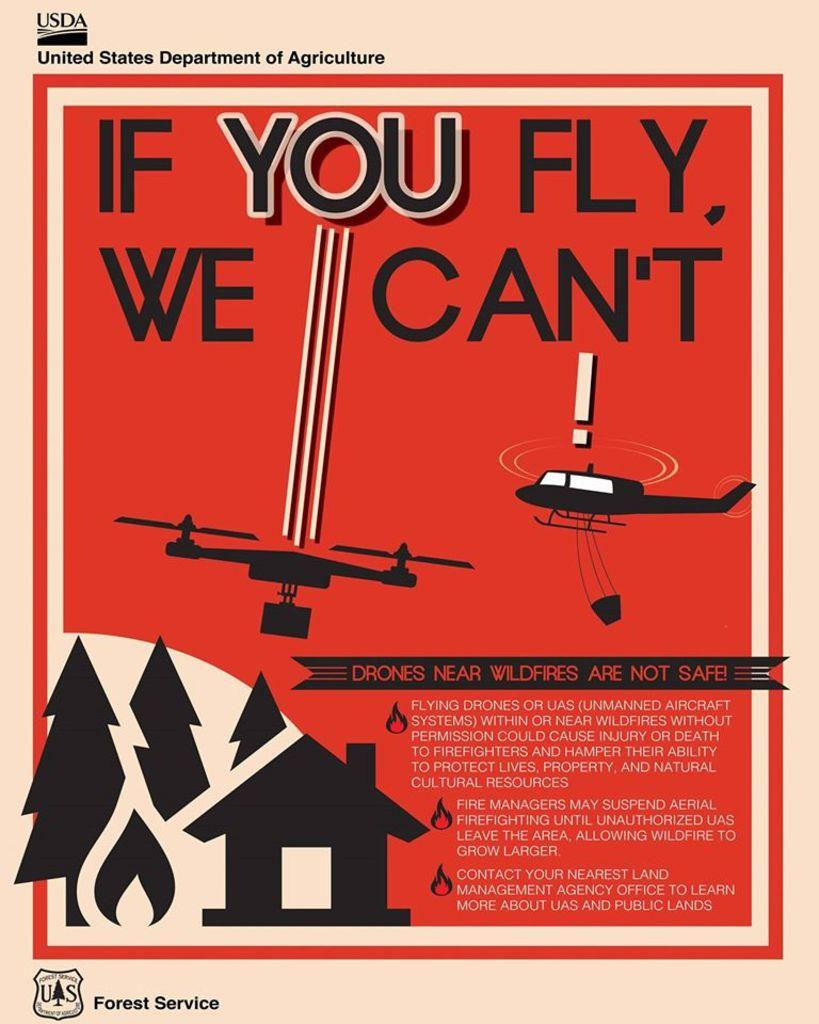What is the main object in the image? There is a poster in the image. What is the color of the poster? The poster is red in color. What can be seen on the poster besides the color? There is text on the poster in red and white colors. What images are depicted on the poster? There is an image of a helicopter and an image of a house on the poster. How does the fog affect the visibility of the helicopter in the image? There is no fog present in the image; it only features a poster with images of a helicopter and a house. 